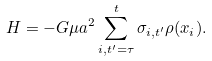Convert formula to latex. <formula><loc_0><loc_0><loc_500><loc_500>H = - G \mu a ^ { 2 } \sum _ { i , t ^ { \prime } = \tau } ^ { t } \sigma _ { i , t ^ { \prime } } \rho ( { x } _ { i } ) .</formula> 